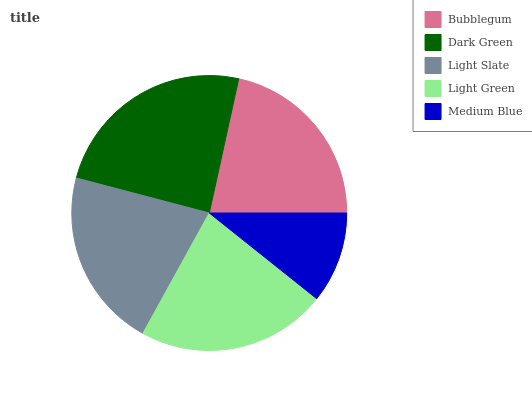Is Medium Blue the minimum?
Answer yes or no. Yes. Is Dark Green the maximum?
Answer yes or no. Yes. Is Light Slate the minimum?
Answer yes or no. No. Is Light Slate the maximum?
Answer yes or no. No. Is Dark Green greater than Light Slate?
Answer yes or no. Yes. Is Light Slate less than Dark Green?
Answer yes or no. Yes. Is Light Slate greater than Dark Green?
Answer yes or no. No. Is Dark Green less than Light Slate?
Answer yes or no. No. Is Bubblegum the high median?
Answer yes or no. Yes. Is Bubblegum the low median?
Answer yes or no. Yes. Is Light Slate the high median?
Answer yes or no. No. Is Light Green the low median?
Answer yes or no. No. 